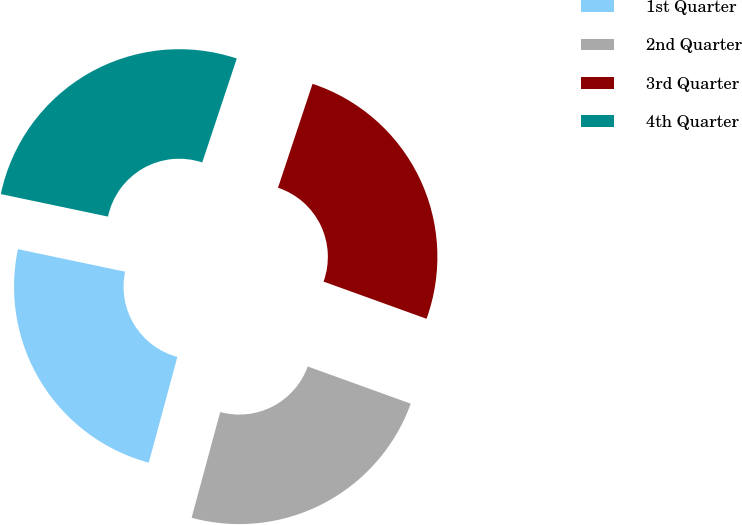Convert chart. <chart><loc_0><loc_0><loc_500><loc_500><pie_chart><fcel>1st Quarter<fcel>2nd Quarter<fcel>3rd Quarter<fcel>4th Quarter<nl><fcel>24.09%<fcel>23.69%<fcel>25.41%<fcel>26.81%<nl></chart> 